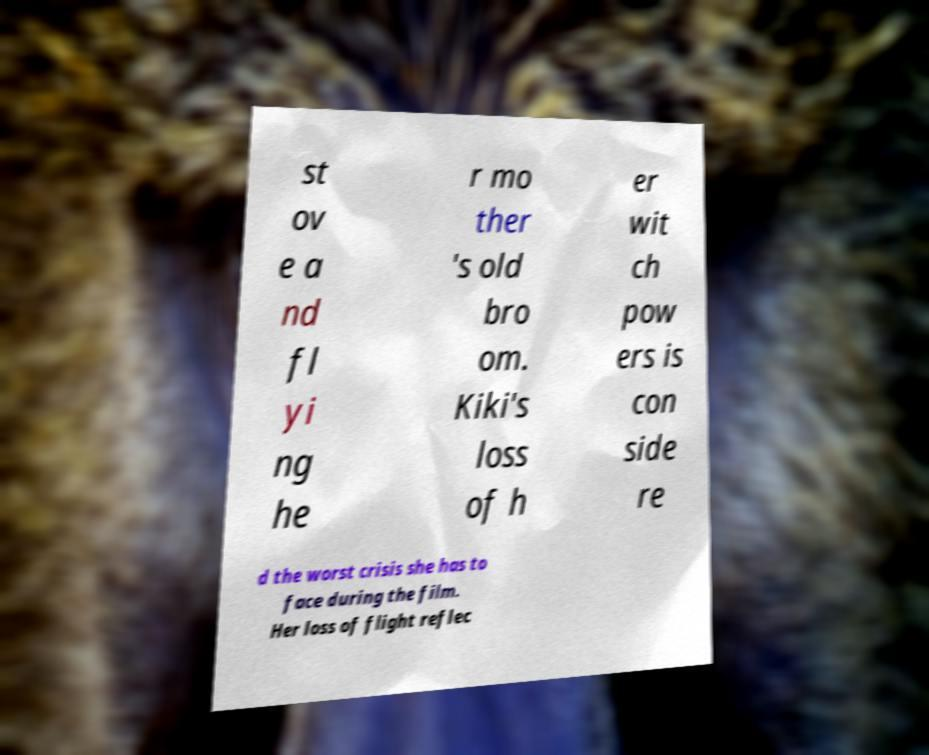Can you read and provide the text displayed in the image?This photo seems to have some interesting text. Can you extract and type it out for me? st ov e a nd fl yi ng he r mo ther 's old bro om. Kiki's loss of h er wit ch pow ers is con side re d the worst crisis she has to face during the film. Her loss of flight reflec 